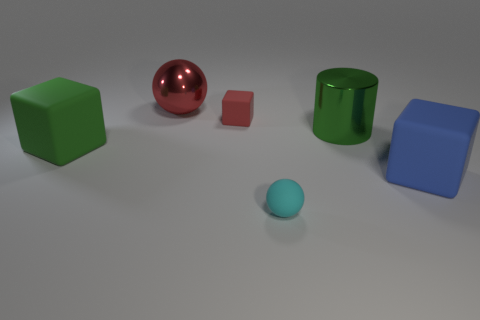There is a big red object; does it have the same shape as the tiny thing behind the cyan object?
Keep it short and to the point. No. Is the number of green rubber cubes that are left of the green matte block greater than the number of large blue things in front of the matte ball?
Provide a succinct answer. No. Is there anything else that has the same color as the tiny ball?
Your response must be concise. No. Are there any large green rubber objects that are in front of the big matte block that is left of the big green object that is right of the metal ball?
Make the answer very short. No. There is a large rubber thing on the right side of the green shiny cylinder; does it have the same shape as the large green metallic object?
Offer a terse response. No. Are there fewer red matte objects in front of the blue rubber cube than small cyan balls in front of the red matte thing?
Make the answer very short. Yes. What is the small cyan thing made of?
Your answer should be very brief. Rubber. Do the small rubber cube and the sphere that is in front of the big blue block have the same color?
Your answer should be compact. No. There is a green cube; what number of big green things are in front of it?
Keep it short and to the point. 0. Is the number of small cubes in front of the large green cylinder less than the number of large green blocks?
Offer a terse response. Yes. 